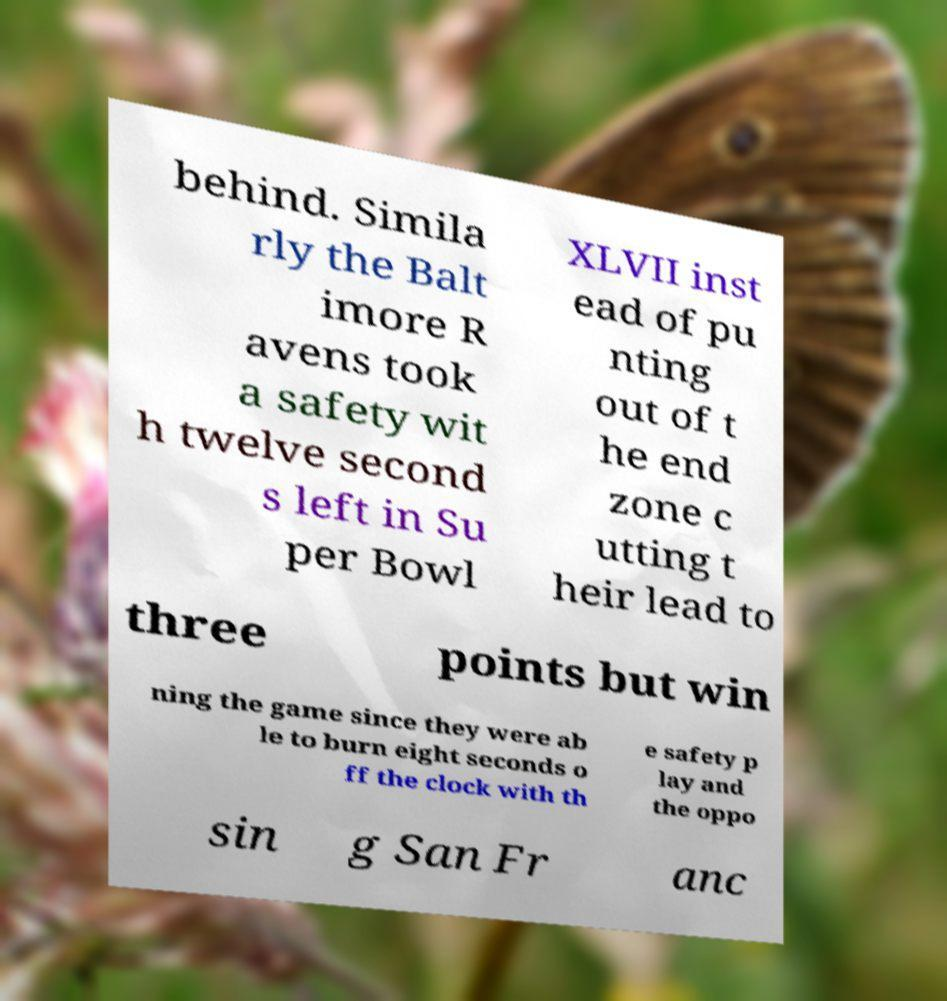Can you accurately transcribe the text from the provided image for me? behind. Simila rly the Balt imore R avens took a safety wit h twelve second s left in Su per Bowl XLVII inst ead of pu nting out of t he end zone c utting t heir lead to three points but win ning the game since they were ab le to burn eight seconds o ff the clock with th e safety p lay and the oppo sin g San Fr anc 